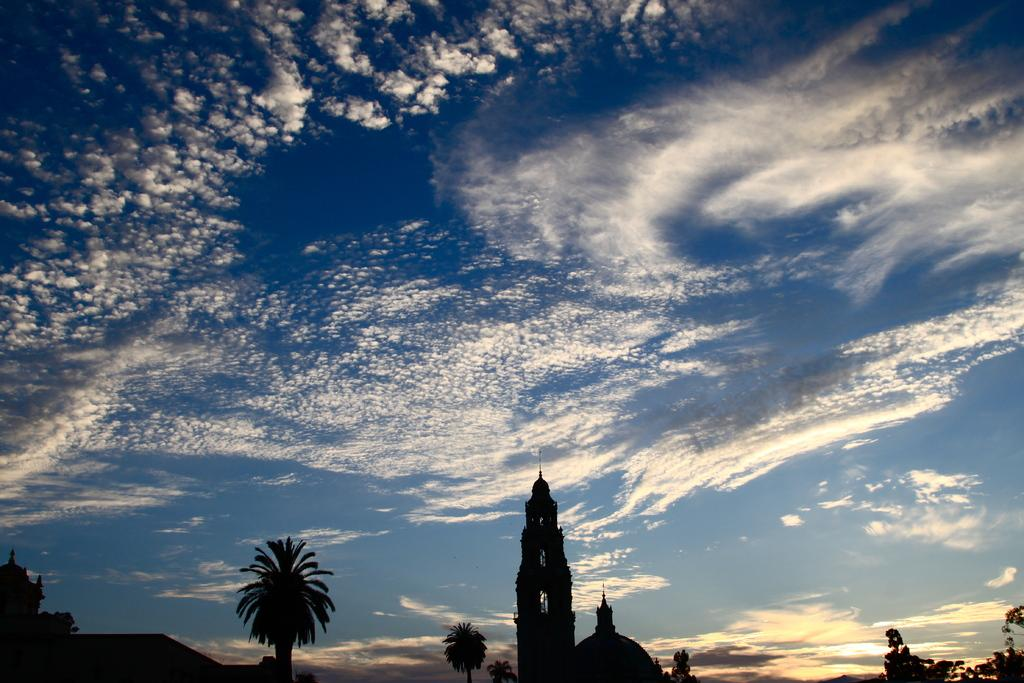What type of natural elements can be seen in the image? There are trees in the image. What type of man-made structures are present in the image? There are buildings in the image. What is visible in the background of the image? The sky is visible in the background of the image. What atmospheric conditions can be observed in the sky? Clouds are present in the sky. Can you describe the woman driving a car in the image? There is no woman driving a car in the image; it only features trees, buildings, and clouds in the sky. 